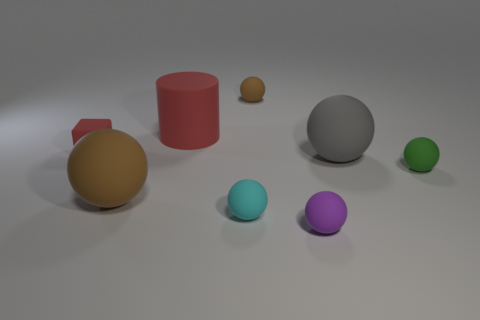Are there an equal number of big matte objects behind the large rubber cylinder and small purple matte balls behind the green ball?
Provide a short and direct response. Yes. There is a brown matte object in front of the small cube; are there any cyan objects that are in front of it?
Provide a short and direct response. Yes. What number of large things are on the right side of the brown thing in front of the brown sphere behind the green rubber sphere?
Keep it short and to the point. 2. Is the number of small cyan matte blocks less than the number of red things?
Your response must be concise. Yes. Do the large brown object behind the tiny purple rubber object and the brown matte thing behind the tiny green ball have the same shape?
Your answer should be compact. Yes. What color is the cylinder?
Offer a very short reply. Red. What number of matte objects are either cyan objects or large things?
Provide a short and direct response. 4. What color is the other big rubber thing that is the same shape as the gray rubber object?
Your answer should be compact. Brown. Are any big purple cylinders visible?
Your answer should be very brief. No. Is the big thing behind the small red thing made of the same material as the brown object in front of the big gray thing?
Ensure brevity in your answer.  Yes. 